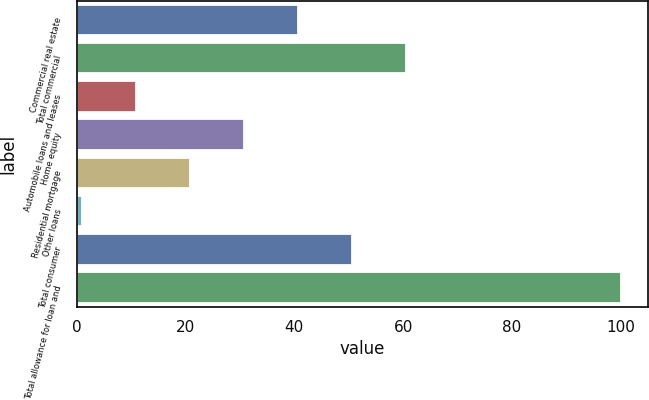<chart> <loc_0><loc_0><loc_500><loc_500><bar_chart><fcel>Commercial real estate<fcel>Total commercial<fcel>Automobile loans and leases<fcel>Home equity<fcel>Residential mortgage<fcel>Other loans<fcel>Total consumer<fcel>Total allowance for loan and<nl><fcel>40.7<fcel>60.5<fcel>11<fcel>30.8<fcel>20.9<fcel>1<fcel>50.6<fcel>100<nl></chart> 